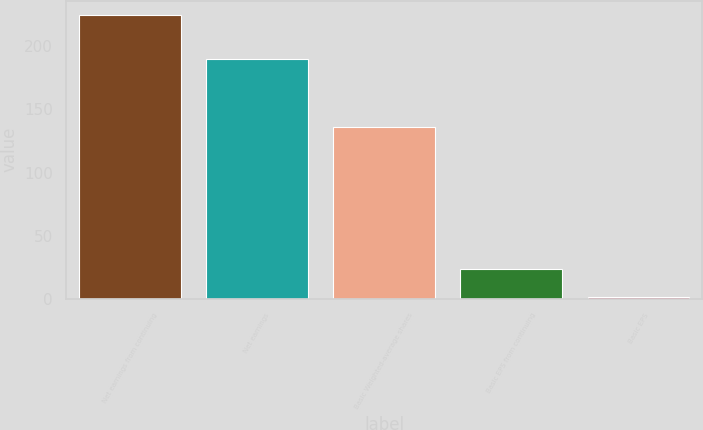Convert chart to OTSL. <chart><loc_0><loc_0><loc_500><loc_500><bar_chart><fcel>Net earnings from continuing<fcel>Net earnings<fcel>Basic Weighted-average shares<fcel>Basic EPS from continuing<fcel>Basic EPS<nl><fcel>225.1<fcel>190<fcel>135.9<fcel>23.77<fcel>1.4<nl></chart> 